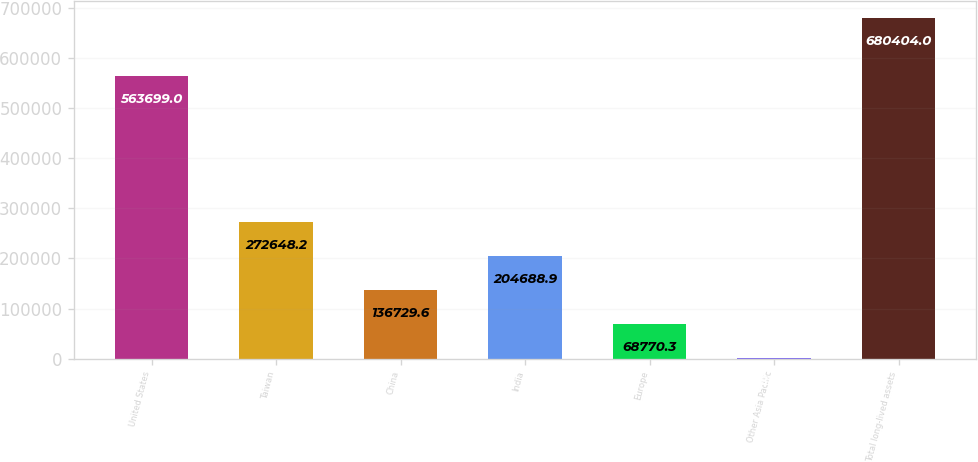<chart> <loc_0><loc_0><loc_500><loc_500><bar_chart><fcel>United States<fcel>Taiwan<fcel>China<fcel>India<fcel>Europe<fcel>Other Asia Pacific<fcel>Total long-lived assets<nl><fcel>563699<fcel>272648<fcel>136730<fcel>204689<fcel>68770.3<fcel>811<fcel>680404<nl></chart> 